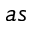Convert formula to latex. <formula><loc_0><loc_0><loc_500><loc_500>a s</formula> 